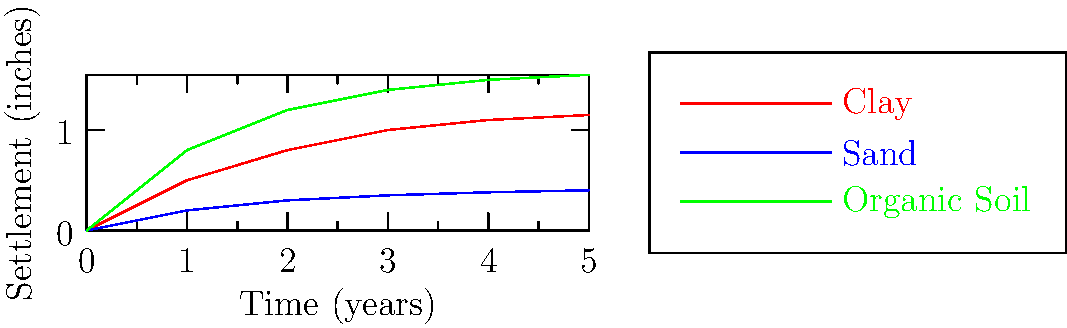A foundation is constructed on three different soil types: clay, sand, and organic soil. Based on the settlement curves shown in the graph, which soil type is likely to cause the most long-term settlement issues, and approximately how much settlement (in inches) would you expect after 5 years? To answer this question, we need to analyze the settlement curves for each soil type:

1. Observe the curves:
   - Red curve represents clay
   - Blue curve represents sand
   - Green curve represents organic soil

2. Compare the final settlement values at 5 years:
   - Clay: approximately 1.15 inches
   - Sand: approximately 0.4 inches
   - Organic Soil: approximately 1.55 inches

3. Identify the soil with the highest settlement:
   The organic soil (green curve) shows the highest settlement at 5 years.

4. Determine the approximate settlement value:
   The organic soil curve reaches about 1.55 inches at the 5-year mark.

5. Consider long-term behavior:
   The organic soil curve also shows the steepest initial slope and continues to increase more rapidly than the other soil types, indicating potential for ongoing settlement issues.

Therefore, the organic soil is likely to cause the most long-term settlement issues, with an expected settlement of approximately 1.55 inches after 5 years.
Answer: Organic soil, 1.55 inches 